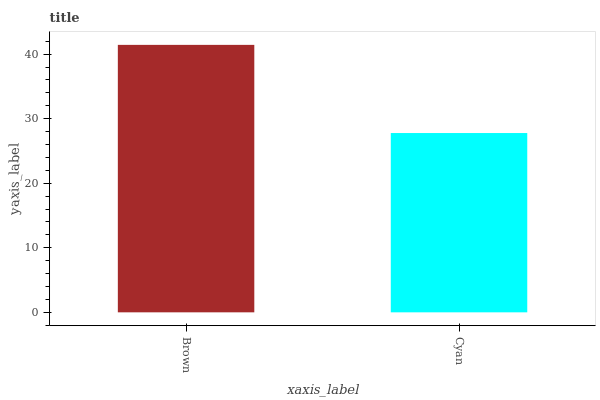Is Cyan the minimum?
Answer yes or no. Yes. Is Brown the maximum?
Answer yes or no. Yes. Is Cyan the maximum?
Answer yes or no. No. Is Brown greater than Cyan?
Answer yes or no. Yes. Is Cyan less than Brown?
Answer yes or no. Yes. Is Cyan greater than Brown?
Answer yes or no. No. Is Brown less than Cyan?
Answer yes or no. No. Is Brown the high median?
Answer yes or no. Yes. Is Cyan the low median?
Answer yes or no. Yes. Is Cyan the high median?
Answer yes or no. No. Is Brown the low median?
Answer yes or no. No. 